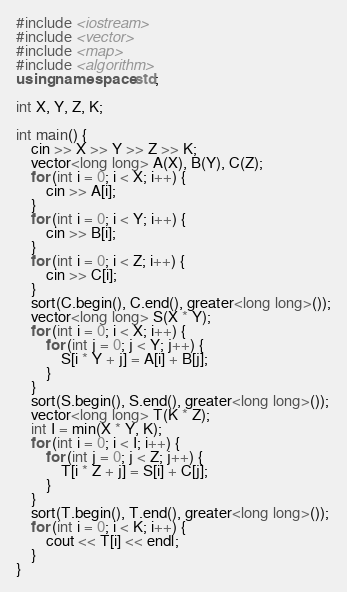<code> <loc_0><loc_0><loc_500><loc_500><_C++_>#include <iostream>
#include <vector>
#include <map>
#include <algorithm>
using namespace std;

int X, Y, Z, K;

int main() {
    cin >> X >> Y >> Z >> K;
    vector<long long> A(X), B(Y), C(Z);
    for (int i = 0; i < X; i++) {
        cin >> A[i];
    }
    for (int i = 0; i < Y; i++) {
        cin >> B[i];
    }
    for (int i = 0; i < Z; i++) {
        cin >> C[i];
    }
    sort(C.begin(), C.end(), greater<long long>());
    vector<long long> S(X * Y);
    for (int i = 0; i < X; i++) {
        for (int j = 0; j < Y; j++) {
            S[i * Y + j] = A[i] + B[j];
        }
    }
    sort(S.begin(), S.end(), greater<long long>());
    vector<long long> T(K * Z);
    int I = min(X * Y, K);
    for (int i = 0; i < I; i++) {
        for (int j = 0; j < Z; j++) {
            T[i * Z + j] = S[i] + C[j];
        }
    }
    sort(T.begin(), T.end(), greater<long long>());
    for (int i = 0; i < K; i++) {
        cout << T[i] << endl;
    }
}


</code> 